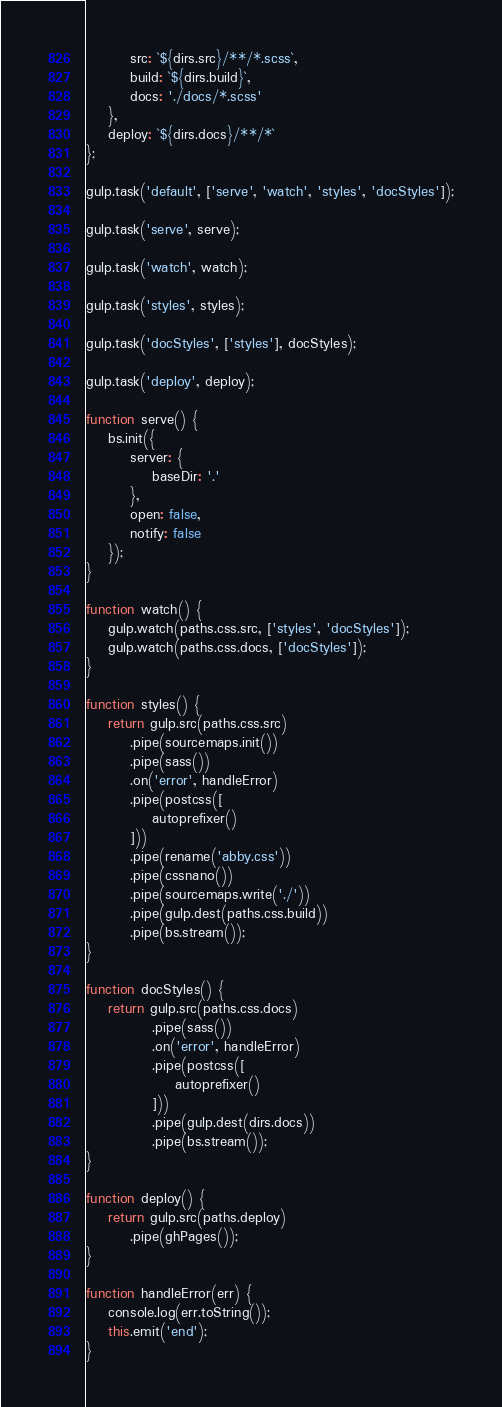<code> <loc_0><loc_0><loc_500><loc_500><_JavaScript_>		src: `${dirs.src}/**/*.scss`,
		build: `${dirs.build}`,
		docs: './docs/*.scss'
	},
	deploy: `${dirs.docs}/**/*`
};

gulp.task('default', ['serve', 'watch', 'styles', 'docStyles']);

gulp.task('serve', serve);

gulp.task('watch', watch);

gulp.task('styles', styles);

gulp.task('docStyles', ['styles'], docStyles);

gulp.task('deploy', deploy);

function serve() {
	bs.init({
		server: {
			baseDir: '.'
		},
		open: false,
		notify: false
	});
}

function watch() {
	gulp.watch(paths.css.src, ['styles', 'docStyles']);
	gulp.watch(paths.css.docs, ['docStyles']);
}

function styles() {
	return gulp.src(paths.css.src)
		.pipe(sourcemaps.init())
		.pipe(sass())
		.on('error', handleError)
		.pipe(postcss([
			autoprefixer()			
		]))
		.pipe(rename('abby.css'))
		.pipe(cssnano())
		.pipe(sourcemaps.write('./'))
		.pipe(gulp.dest(paths.css.build))
		.pipe(bs.stream());
}

function docStyles() {
	return gulp.src(paths.css.docs)
			.pipe(sass())
			.on('error', handleError)
			.pipe(postcss([
				autoprefixer()			
			]))
			.pipe(gulp.dest(dirs.docs))
			.pipe(bs.stream());
}

function deploy() {
	return gulp.src(paths.deploy)
		.pipe(ghPages());
}

function handleError(err) {
	console.log(err.toString());
	this.emit('end');
}</code> 